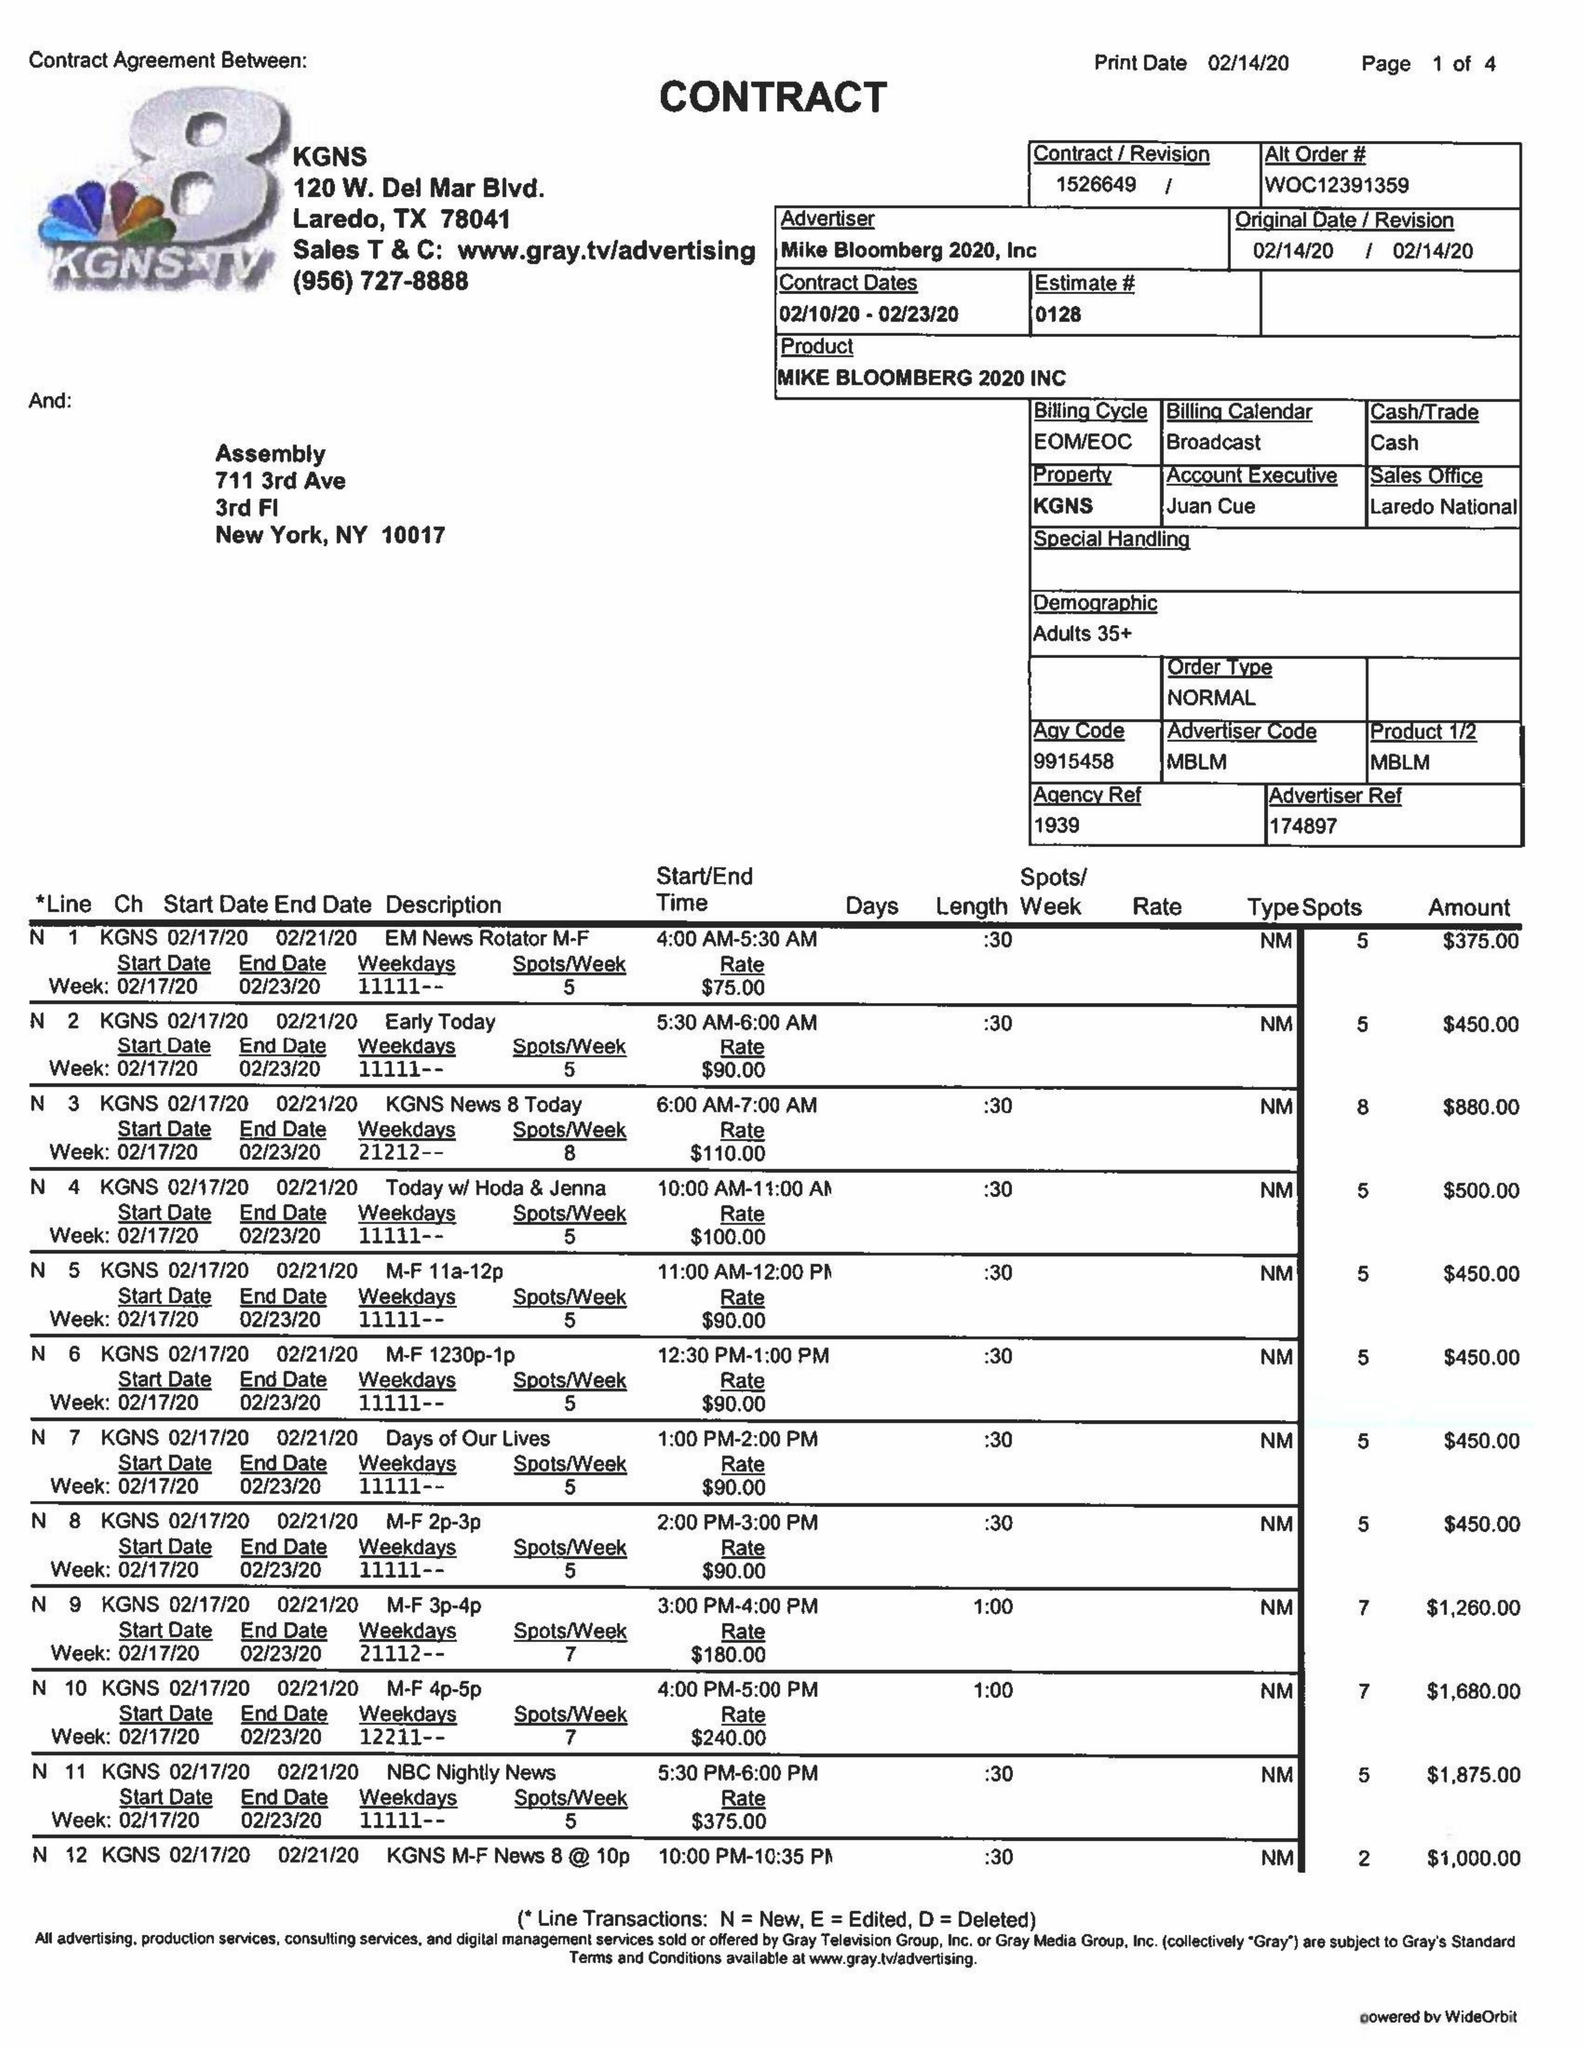What is the value for the flight_to?
Answer the question using a single word or phrase. 02/23/20 